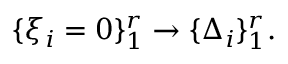<formula> <loc_0><loc_0><loc_500><loc_500>\{ \xi _ { i } = 0 \} _ { 1 } ^ { r } \rightarrow \{ \Delta _ { i } \} _ { 1 } ^ { r } .</formula> 